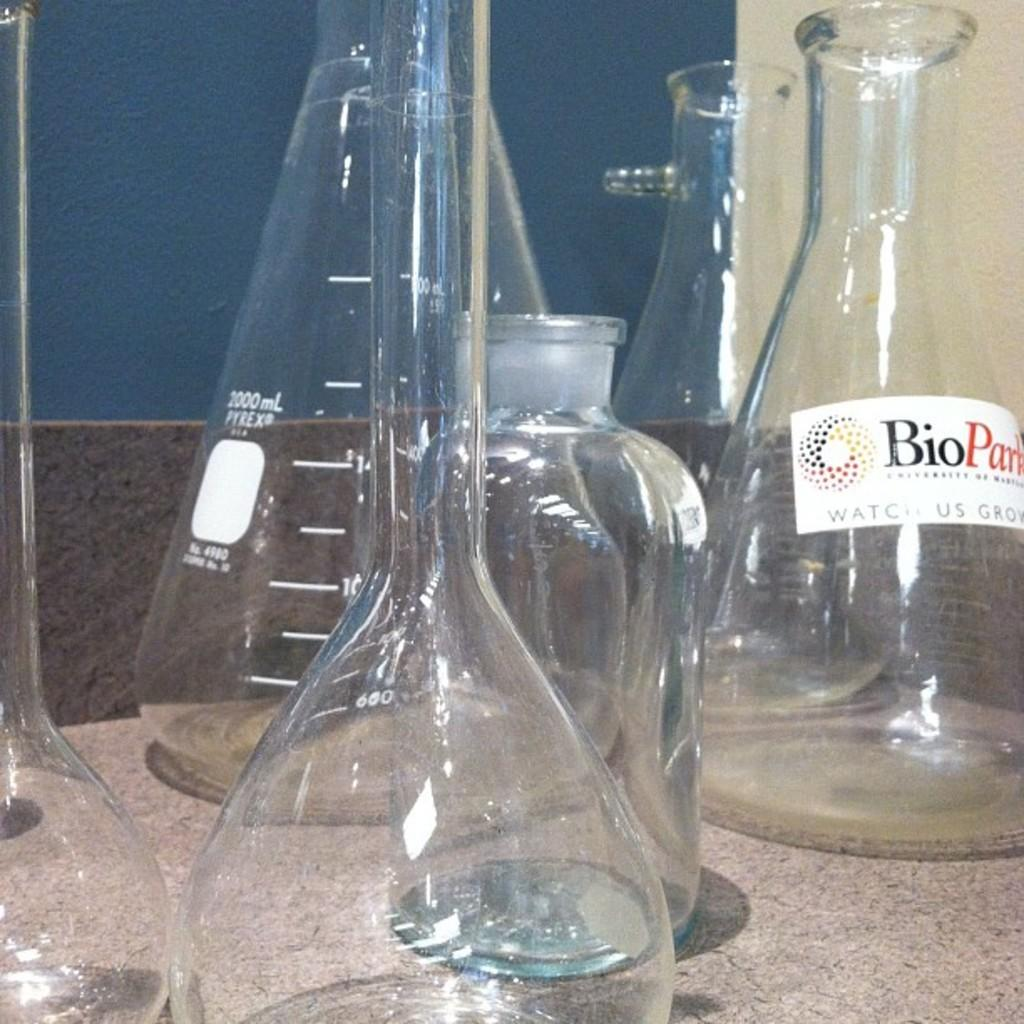<image>
Offer a succinct explanation of the picture presented. Beakers on a table with one titled "BioParts". 